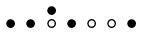Convert formula to latex. <formula><loc_0><loc_0><loc_500><loc_500>\begin{smallmatrix} & & \bullet \\ \bullet & \bullet & \circ & \bullet & \circ & \circ & \bullet & \\ \end{smallmatrix}</formula> 